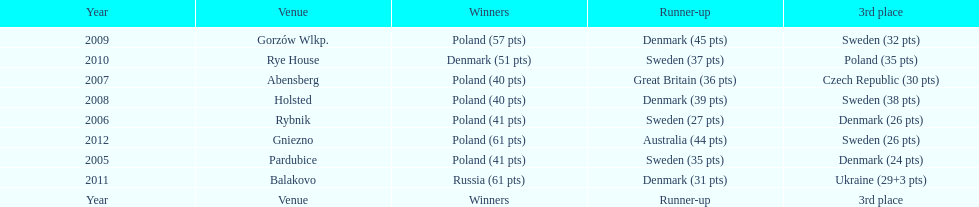Previous to 2008 how many times was sweden the runner up? 2. Would you mind parsing the complete table? {'header': ['Year', 'Venue', 'Winners', 'Runner-up', '3rd place'], 'rows': [['2009', 'Gorzów Wlkp.', 'Poland (57 pts)', 'Denmark (45 pts)', 'Sweden (32 pts)'], ['2010', 'Rye House', 'Denmark (51 pts)', 'Sweden (37 pts)', 'Poland (35 pts)'], ['2007', 'Abensberg', 'Poland (40 pts)', 'Great Britain (36 pts)', 'Czech Republic (30 pts)'], ['2008', 'Holsted', 'Poland (40 pts)', 'Denmark (39 pts)', 'Sweden (38 pts)'], ['2006', 'Rybnik', 'Poland (41 pts)', 'Sweden (27 pts)', 'Denmark (26 pts)'], ['2012', 'Gniezno', 'Poland (61 pts)', 'Australia (44 pts)', 'Sweden (26 pts)'], ['2005', 'Pardubice', 'Poland (41 pts)', 'Sweden (35 pts)', 'Denmark (24 pts)'], ['2011', 'Balakovo', 'Russia (61 pts)', 'Denmark (31 pts)', 'Ukraine (29+3 pts)'], ['Year', 'Venue', 'Winners', 'Runner-up', '3rd place']]} 